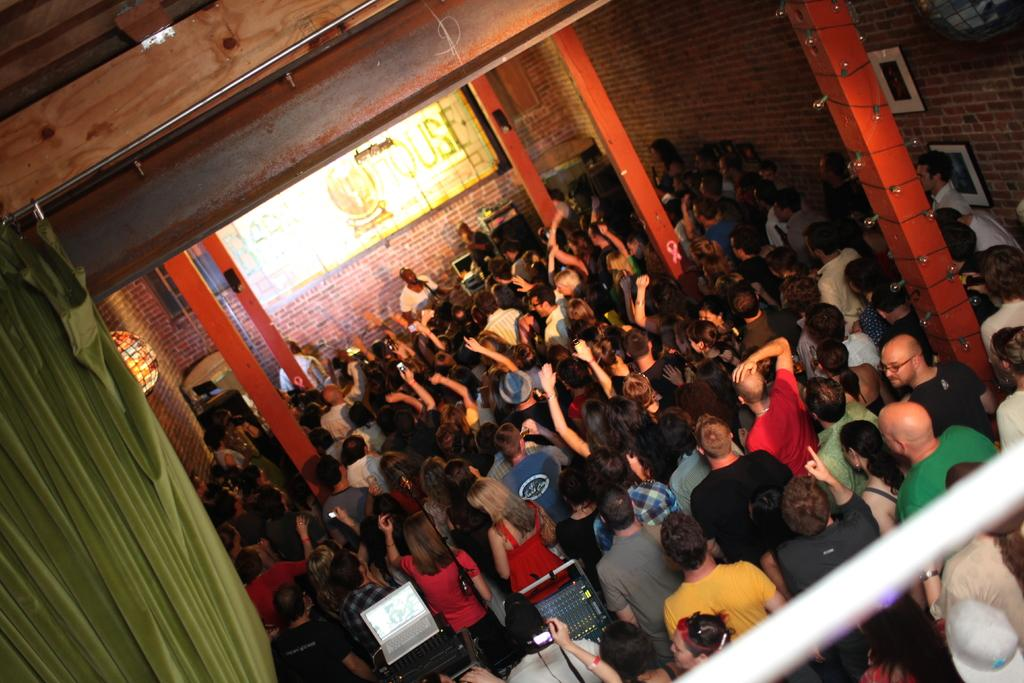How many people are in the image? There is a group of people in the image. Where are the people standing? The people are standing in a hall. What architectural features can be seen in the hall? There are pillars, curtains, and walls in the hall. What type of quince is being served in the hall? There is no mention of quince or any food being served in the image. 